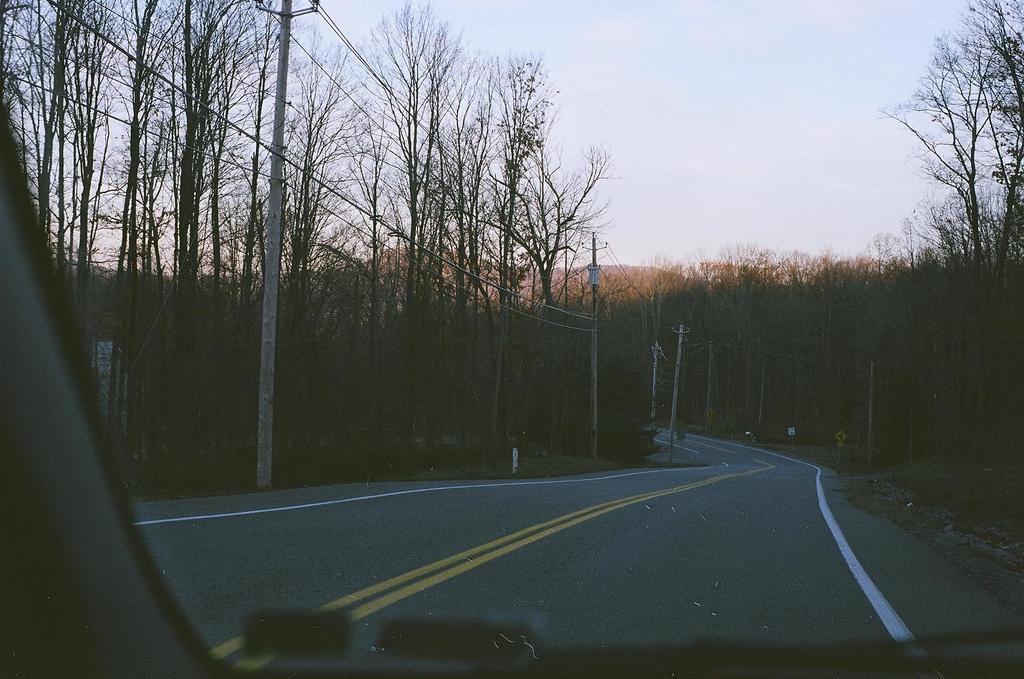Could you give a brief overview of what you see in this image? In this picture we can observe a road. There are some poles and wires on the side of the road. We can observe trees and a vehicle. In the background there are hills and a sky. 